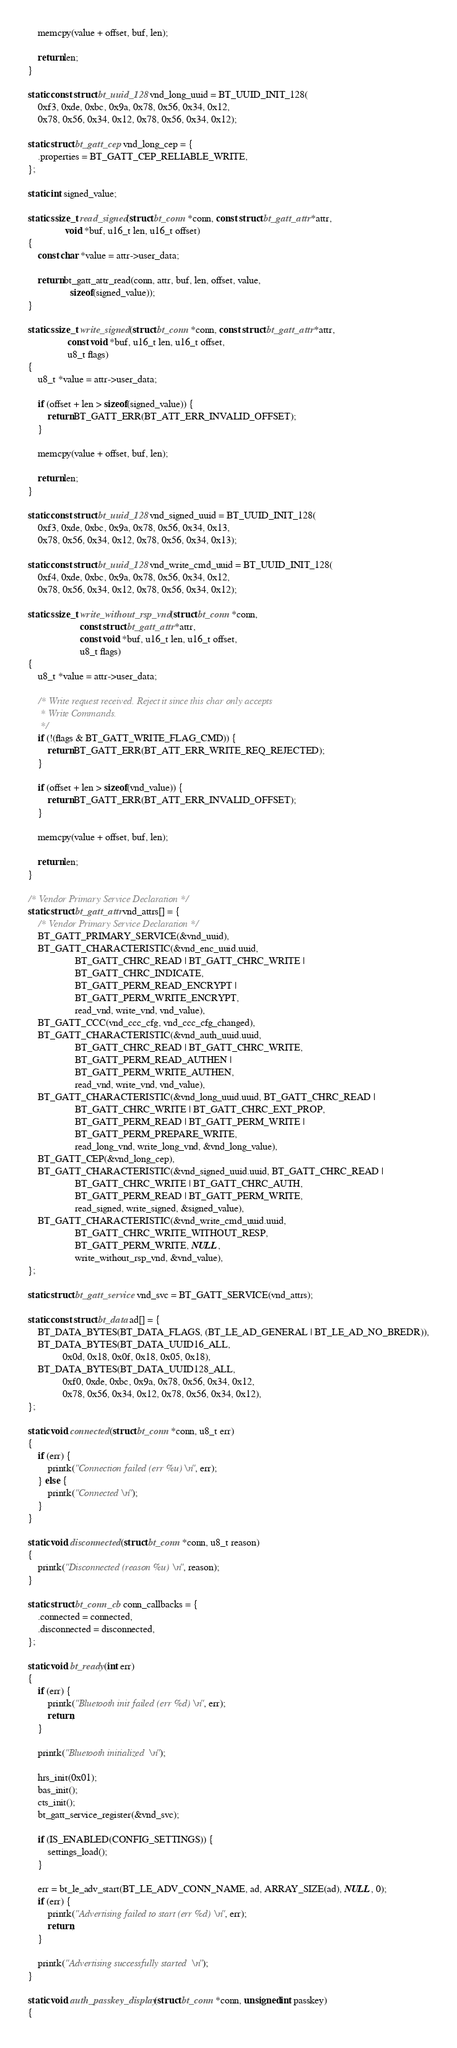Convert code to text. <code><loc_0><loc_0><loc_500><loc_500><_C_>	memcpy(value + offset, buf, len);

	return len;
}

static const struct bt_uuid_128 vnd_long_uuid = BT_UUID_INIT_128(
	0xf3, 0xde, 0xbc, 0x9a, 0x78, 0x56, 0x34, 0x12,
	0x78, 0x56, 0x34, 0x12, 0x78, 0x56, 0x34, 0x12);

static struct bt_gatt_cep vnd_long_cep = {
	.properties = BT_GATT_CEP_RELIABLE_WRITE,
};

static int signed_value;

static ssize_t read_signed(struct bt_conn *conn, const struct bt_gatt_attr *attr,
			   void *buf, u16_t len, u16_t offset)
{
	const char *value = attr->user_data;

	return bt_gatt_attr_read(conn, attr, buf, len, offset, value,
				 sizeof(signed_value));
}

static ssize_t write_signed(struct bt_conn *conn, const struct bt_gatt_attr *attr,
			    const void *buf, u16_t len, u16_t offset,
			    u8_t flags)
{
	u8_t *value = attr->user_data;

	if (offset + len > sizeof(signed_value)) {
		return BT_GATT_ERR(BT_ATT_ERR_INVALID_OFFSET);
	}

	memcpy(value + offset, buf, len);

	return len;
}

static const struct bt_uuid_128 vnd_signed_uuid = BT_UUID_INIT_128(
	0xf3, 0xde, 0xbc, 0x9a, 0x78, 0x56, 0x34, 0x13,
	0x78, 0x56, 0x34, 0x12, 0x78, 0x56, 0x34, 0x13);

static const struct bt_uuid_128 vnd_write_cmd_uuid = BT_UUID_INIT_128(
	0xf4, 0xde, 0xbc, 0x9a, 0x78, 0x56, 0x34, 0x12,
	0x78, 0x56, 0x34, 0x12, 0x78, 0x56, 0x34, 0x12);

static ssize_t write_without_rsp_vnd(struct bt_conn *conn,
				     const struct bt_gatt_attr *attr,
				     const void *buf, u16_t len, u16_t offset,
				     u8_t flags)
{
	u8_t *value = attr->user_data;

	/* Write request received. Reject it since this char only accepts
	 * Write Commands.
	 */
	if (!(flags & BT_GATT_WRITE_FLAG_CMD)) {
		return BT_GATT_ERR(BT_ATT_ERR_WRITE_REQ_REJECTED);
	}

	if (offset + len > sizeof(vnd_value)) {
		return BT_GATT_ERR(BT_ATT_ERR_INVALID_OFFSET);
	}

	memcpy(value + offset, buf, len);

	return len;
}

/* Vendor Primary Service Declaration */
static struct bt_gatt_attr vnd_attrs[] = {
	/* Vendor Primary Service Declaration */
	BT_GATT_PRIMARY_SERVICE(&vnd_uuid),
	BT_GATT_CHARACTERISTIC(&vnd_enc_uuid.uuid,
			       BT_GATT_CHRC_READ | BT_GATT_CHRC_WRITE |
			       BT_GATT_CHRC_INDICATE,
			       BT_GATT_PERM_READ_ENCRYPT |
			       BT_GATT_PERM_WRITE_ENCRYPT,
			       read_vnd, write_vnd, vnd_value),
	BT_GATT_CCC(vnd_ccc_cfg, vnd_ccc_cfg_changed),
	BT_GATT_CHARACTERISTIC(&vnd_auth_uuid.uuid,
			       BT_GATT_CHRC_READ | BT_GATT_CHRC_WRITE,
			       BT_GATT_PERM_READ_AUTHEN |
			       BT_GATT_PERM_WRITE_AUTHEN,
			       read_vnd, write_vnd, vnd_value),
	BT_GATT_CHARACTERISTIC(&vnd_long_uuid.uuid, BT_GATT_CHRC_READ |
			       BT_GATT_CHRC_WRITE | BT_GATT_CHRC_EXT_PROP,
			       BT_GATT_PERM_READ | BT_GATT_PERM_WRITE |
			       BT_GATT_PERM_PREPARE_WRITE,
			       read_long_vnd, write_long_vnd, &vnd_long_value),
	BT_GATT_CEP(&vnd_long_cep),
	BT_GATT_CHARACTERISTIC(&vnd_signed_uuid.uuid, BT_GATT_CHRC_READ |
			       BT_GATT_CHRC_WRITE | BT_GATT_CHRC_AUTH,
			       BT_GATT_PERM_READ | BT_GATT_PERM_WRITE,
			       read_signed, write_signed, &signed_value),
	BT_GATT_CHARACTERISTIC(&vnd_write_cmd_uuid.uuid,
			       BT_GATT_CHRC_WRITE_WITHOUT_RESP,
			       BT_GATT_PERM_WRITE, NULL,
			       write_without_rsp_vnd, &vnd_value),
};

static struct bt_gatt_service vnd_svc = BT_GATT_SERVICE(vnd_attrs);

static const struct bt_data ad[] = {
	BT_DATA_BYTES(BT_DATA_FLAGS, (BT_LE_AD_GENERAL | BT_LE_AD_NO_BREDR)),
	BT_DATA_BYTES(BT_DATA_UUID16_ALL,
		      0x0d, 0x18, 0x0f, 0x18, 0x05, 0x18),
	BT_DATA_BYTES(BT_DATA_UUID128_ALL,
		      0xf0, 0xde, 0xbc, 0x9a, 0x78, 0x56, 0x34, 0x12,
		      0x78, 0x56, 0x34, 0x12, 0x78, 0x56, 0x34, 0x12),
};

static void connected(struct bt_conn *conn, u8_t err)
{
	if (err) {
		printk("Connection failed (err %u)\n", err);
	} else {
		printk("Connected\n");
	}
}

static void disconnected(struct bt_conn *conn, u8_t reason)
{
	printk("Disconnected (reason %u)\n", reason);
}

static struct bt_conn_cb conn_callbacks = {
	.connected = connected,
	.disconnected = disconnected,
};

static void bt_ready(int err)
{
	if (err) {
		printk("Bluetooth init failed (err %d)\n", err);
		return;
	}

	printk("Bluetooth initialized\n");

	hrs_init(0x01);
	bas_init();
	cts_init();
	bt_gatt_service_register(&vnd_svc);

	if (IS_ENABLED(CONFIG_SETTINGS)) {
		settings_load();
	}

	err = bt_le_adv_start(BT_LE_ADV_CONN_NAME, ad, ARRAY_SIZE(ad), NULL, 0);
	if (err) {
		printk("Advertising failed to start (err %d)\n", err);
		return;
	}

	printk("Advertising successfully started\n");
}

static void auth_passkey_display(struct bt_conn *conn, unsigned int passkey)
{</code> 